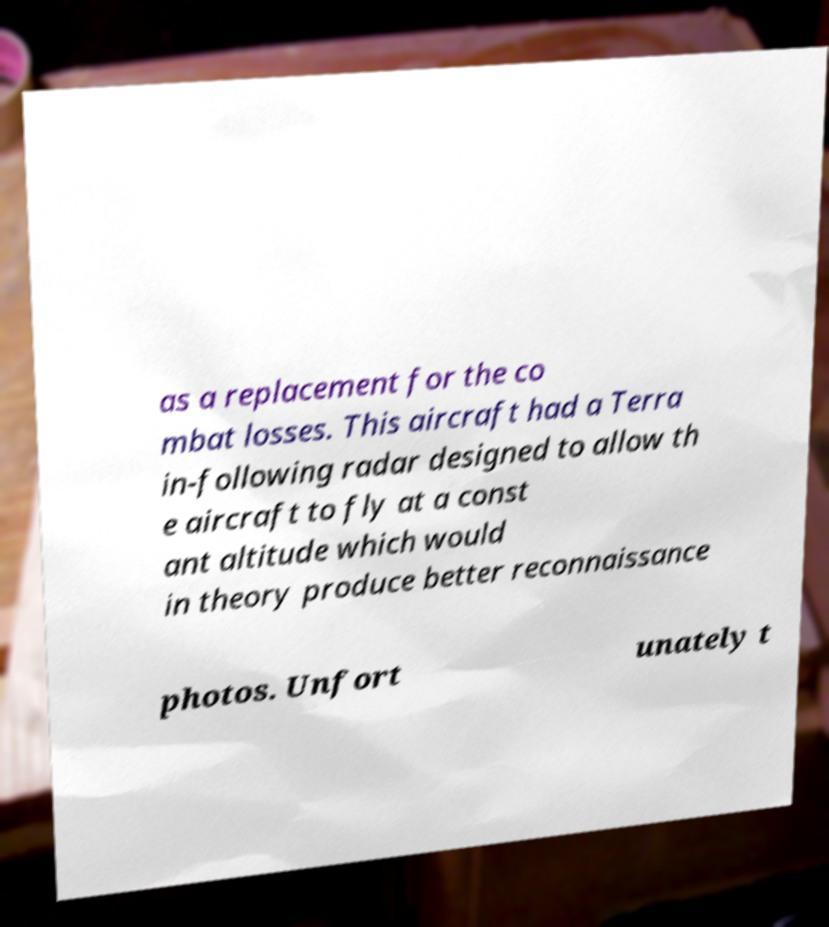Please read and relay the text visible in this image. What does it say? as a replacement for the co mbat losses. This aircraft had a Terra in-following radar designed to allow th e aircraft to fly at a const ant altitude which would in theory produce better reconnaissance photos. Unfort unately t 